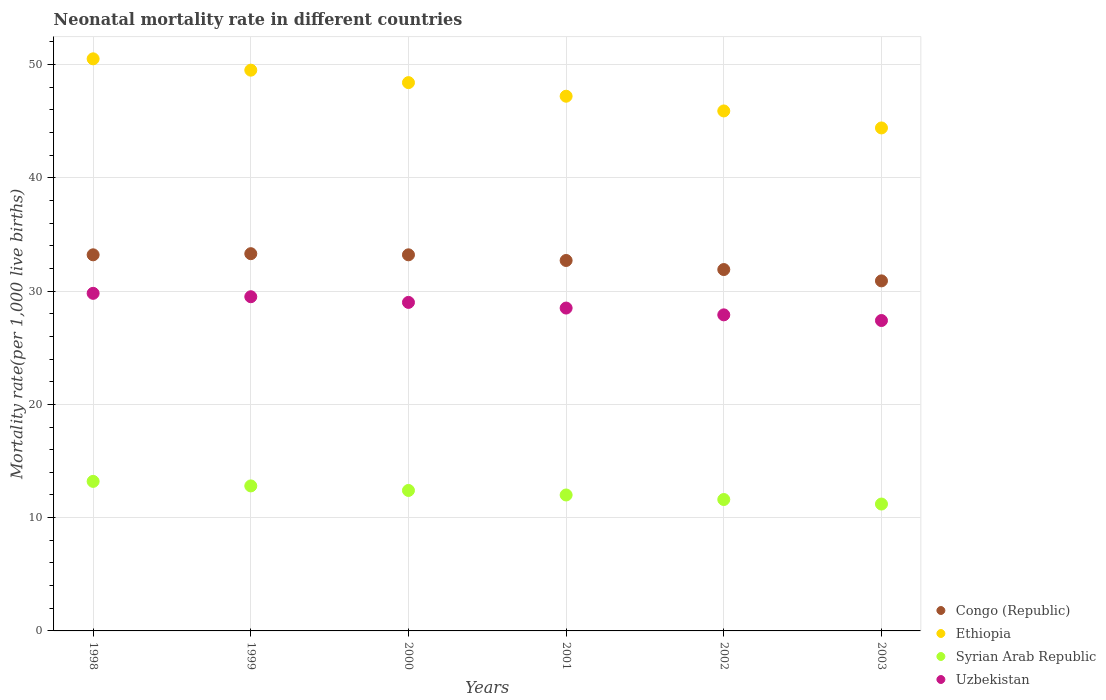What is the neonatal mortality rate in Uzbekistan in 2002?
Provide a succinct answer. 27.9. Across all years, what is the maximum neonatal mortality rate in Ethiopia?
Give a very brief answer. 50.5. Across all years, what is the minimum neonatal mortality rate in Congo (Republic)?
Keep it short and to the point. 30.9. In which year was the neonatal mortality rate in Congo (Republic) maximum?
Your answer should be compact. 1999. What is the total neonatal mortality rate in Syrian Arab Republic in the graph?
Your answer should be very brief. 73.2. What is the difference between the neonatal mortality rate in Ethiopia in 1998 and the neonatal mortality rate in Congo (Republic) in 1999?
Your response must be concise. 17.2. What is the average neonatal mortality rate in Congo (Republic) per year?
Provide a short and direct response. 32.53. In the year 1999, what is the difference between the neonatal mortality rate in Ethiopia and neonatal mortality rate in Syrian Arab Republic?
Your response must be concise. 36.7. In how many years, is the neonatal mortality rate in Uzbekistan greater than 14?
Offer a terse response. 6. What is the ratio of the neonatal mortality rate in Congo (Republic) in 1999 to that in 2000?
Make the answer very short. 1. Is the neonatal mortality rate in Ethiopia in 1998 less than that in 2000?
Make the answer very short. No. Is the difference between the neonatal mortality rate in Ethiopia in 1998 and 2000 greater than the difference between the neonatal mortality rate in Syrian Arab Republic in 1998 and 2000?
Make the answer very short. Yes. What is the difference between the highest and the second highest neonatal mortality rate in Congo (Republic)?
Your answer should be compact. 0.1. In how many years, is the neonatal mortality rate in Uzbekistan greater than the average neonatal mortality rate in Uzbekistan taken over all years?
Provide a succinct answer. 3. Is the sum of the neonatal mortality rate in Uzbekistan in 1998 and 1999 greater than the maximum neonatal mortality rate in Syrian Arab Republic across all years?
Offer a very short reply. Yes. Is it the case that in every year, the sum of the neonatal mortality rate in Congo (Republic) and neonatal mortality rate in Ethiopia  is greater than the sum of neonatal mortality rate in Uzbekistan and neonatal mortality rate in Syrian Arab Republic?
Give a very brief answer. Yes. Is it the case that in every year, the sum of the neonatal mortality rate in Uzbekistan and neonatal mortality rate in Ethiopia  is greater than the neonatal mortality rate in Syrian Arab Republic?
Offer a very short reply. Yes. Does the neonatal mortality rate in Syrian Arab Republic monotonically increase over the years?
Your answer should be very brief. No. How many dotlines are there?
Provide a short and direct response. 4. How many years are there in the graph?
Ensure brevity in your answer.  6. Are the values on the major ticks of Y-axis written in scientific E-notation?
Provide a short and direct response. No. How many legend labels are there?
Ensure brevity in your answer.  4. How are the legend labels stacked?
Your answer should be very brief. Vertical. What is the title of the graph?
Keep it short and to the point. Neonatal mortality rate in different countries. What is the label or title of the X-axis?
Provide a short and direct response. Years. What is the label or title of the Y-axis?
Provide a short and direct response. Mortality rate(per 1,0 live births). What is the Mortality rate(per 1,000 live births) in Congo (Republic) in 1998?
Provide a short and direct response. 33.2. What is the Mortality rate(per 1,000 live births) of Ethiopia in 1998?
Your answer should be very brief. 50.5. What is the Mortality rate(per 1,000 live births) of Syrian Arab Republic in 1998?
Ensure brevity in your answer.  13.2. What is the Mortality rate(per 1,000 live births) of Uzbekistan in 1998?
Your answer should be compact. 29.8. What is the Mortality rate(per 1,000 live births) in Congo (Republic) in 1999?
Your answer should be compact. 33.3. What is the Mortality rate(per 1,000 live births) of Ethiopia in 1999?
Provide a short and direct response. 49.5. What is the Mortality rate(per 1,000 live births) in Uzbekistan in 1999?
Your response must be concise. 29.5. What is the Mortality rate(per 1,000 live births) in Congo (Republic) in 2000?
Give a very brief answer. 33.2. What is the Mortality rate(per 1,000 live births) of Ethiopia in 2000?
Provide a short and direct response. 48.4. What is the Mortality rate(per 1,000 live births) of Uzbekistan in 2000?
Give a very brief answer. 29. What is the Mortality rate(per 1,000 live births) in Congo (Republic) in 2001?
Your answer should be compact. 32.7. What is the Mortality rate(per 1,000 live births) of Ethiopia in 2001?
Your response must be concise. 47.2. What is the Mortality rate(per 1,000 live births) in Uzbekistan in 2001?
Offer a terse response. 28.5. What is the Mortality rate(per 1,000 live births) of Congo (Republic) in 2002?
Provide a short and direct response. 31.9. What is the Mortality rate(per 1,000 live births) of Ethiopia in 2002?
Offer a terse response. 45.9. What is the Mortality rate(per 1,000 live births) of Uzbekistan in 2002?
Your answer should be very brief. 27.9. What is the Mortality rate(per 1,000 live births) of Congo (Republic) in 2003?
Your answer should be very brief. 30.9. What is the Mortality rate(per 1,000 live births) of Ethiopia in 2003?
Provide a short and direct response. 44.4. What is the Mortality rate(per 1,000 live births) of Uzbekistan in 2003?
Offer a terse response. 27.4. Across all years, what is the maximum Mortality rate(per 1,000 live births) of Congo (Republic)?
Ensure brevity in your answer.  33.3. Across all years, what is the maximum Mortality rate(per 1,000 live births) in Ethiopia?
Your answer should be very brief. 50.5. Across all years, what is the maximum Mortality rate(per 1,000 live births) in Syrian Arab Republic?
Provide a short and direct response. 13.2. Across all years, what is the maximum Mortality rate(per 1,000 live births) in Uzbekistan?
Provide a succinct answer. 29.8. Across all years, what is the minimum Mortality rate(per 1,000 live births) in Congo (Republic)?
Your answer should be compact. 30.9. Across all years, what is the minimum Mortality rate(per 1,000 live births) of Ethiopia?
Offer a terse response. 44.4. Across all years, what is the minimum Mortality rate(per 1,000 live births) in Uzbekistan?
Your response must be concise. 27.4. What is the total Mortality rate(per 1,000 live births) in Congo (Republic) in the graph?
Offer a very short reply. 195.2. What is the total Mortality rate(per 1,000 live births) in Ethiopia in the graph?
Give a very brief answer. 285.9. What is the total Mortality rate(per 1,000 live births) in Syrian Arab Republic in the graph?
Keep it short and to the point. 73.2. What is the total Mortality rate(per 1,000 live births) in Uzbekistan in the graph?
Your answer should be very brief. 172.1. What is the difference between the Mortality rate(per 1,000 live births) in Congo (Republic) in 1998 and that in 1999?
Your answer should be very brief. -0.1. What is the difference between the Mortality rate(per 1,000 live births) in Ethiopia in 1998 and that in 1999?
Your answer should be compact. 1. What is the difference between the Mortality rate(per 1,000 live births) of Syrian Arab Republic in 1998 and that in 1999?
Your answer should be very brief. 0.4. What is the difference between the Mortality rate(per 1,000 live births) of Uzbekistan in 1998 and that in 1999?
Make the answer very short. 0.3. What is the difference between the Mortality rate(per 1,000 live births) of Congo (Republic) in 1998 and that in 2000?
Give a very brief answer. 0. What is the difference between the Mortality rate(per 1,000 live births) of Ethiopia in 1998 and that in 2001?
Make the answer very short. 3.3. What is the difference between the Mortality rate(per 1,000 live births) of Syrian Arab Republic in 1998 and that in 2001?
Provide a succinct answer. 1.2. What is the difference between the Mortality rate(per 1,000 live births) of Uzbekistan in 1998 and that in 2001?
Provide a succinct answer. 1.3. What is the difference between the Mortality rate(per 1,000 live births) of Congo (Republic) in 1998 and that in 2002?
Your answer should be very brief. 1.3. What is the difference between the Mortality rate(per 1,000 live births) in Ethiopia in 1998 and that in 2002?
Your answer should be very brief. 4.6. What is the difference between the Mortality rate(per 1,000 live births) in Syrian Arab Republic in 1998 and that in 2002?
Your response must be concise. 1.6. What is the difference between the Mortality rate(per 1,000 live births) in Uzbekistan in 1998 and that in 2002?
Offer a very short reply. 1.9. What is the difference between the Mortality rate(per 1,000 live births) in Syrian Arab Republic in 1998 and that in 2003?
Provide a succinct answer. 2. What is the difference between the Mortality rate(per 1,000 live births) of Uzbekistan in 1998 and that in 2003?
Your answer should be compact. 2.4. What is the difference between the Mortality rate(per 1,000 live births) in Congo (Republic) in 1999 and that in 2000?
Your response must be concise. 0.1. What is the difference between the Mortality rate(per 1,000 live births) in Ethiopia in 1999 and that in 2000?
Your answer should be compact. 1.1. What is the difference between the Mortality rate(per 1,000 live births) in Syrian Arab Republic in 1999 and that in 2000?
Offer a terse response. 0.4. What is the difference between the Mortality rate(per 1,000 live births) in Uzbekistan in 1999 and that in 2000?
Your response must be concise. 0.5. What is the difference between the Mortality rate(per 1,000 live births) of Congo (Republic) in 1999 and that in 2001?
Your answer should be compact. 0.6. What is the difference between the Mortality rate(per 1,000 live births) of Uzbekistan in 1999 and that in 2001?
Your response must be concise. 1. What is the difference between the Mortality rate(per 1,000 live births) of Congo (Republic) in 1999 and that in 2003?
Provide a short and direct response. 2.4. What is the difference between the Mortality rate(per 1,000 live births) of Ethiopia in 2000 and that in 2001?
Offer a very short reply. 1.2. What is the difference between the Mortality rate(per 1,000 live births) of Syrian Arab Republic in 2000 and that in 2001?
Keep it short and to the point. 0.4. What is the difference between the Mortality rate(per 1,000 live births) in Uzbekistan in 2000 and that in 2001?
Your response must be concise. 0.5. What is the difference between the Mortality rate(per 1,000 live births) in Congo (Republic) in 2000 and that in 2002?
Keep it short and to the point. 1.3. What is the difference between the Mortality rate(per 1,000 live births) in Syrian Arab Republic in 2000 and that in 2002?
Give a very brief answer. 0.8. What is the difference between the Mortality rate(per 1,000 live births) in Ethiopia in 2000 and that in 2003?
Offer a terse response. 4. What is the difference between the Mortality rate(per 1,000 live births) of Syrian Arab Republic in 2000 and that in 2003?
Your response must be concise. 1.2. What is the difference between the Mortality rate(per 1,000 live births) in Uzbekistan in 2000 and that in 2003?
Your answer should be compact. 1.6. What is the difference between the Mortality rate(per 1,000 live births) of Congo (Republic) in 2001 and that in 2002?
Offer a very short reply. 0.8. What is the difference between the Mortality rate(per 1,000 live births) of Ethiopia in 2001 and that in 2002?
Your response must be concise. 1.3. What is the difference between the Mortality rate(per 1,000 live births) in Uzbekistan in 2001 and that in 2002?
Ensure brevity in your answer.  0.6. What is the difference between the Mortality rate(per 1,000 live births) of Ethiopia in 2001 and that in 2003?
Your response must be concise. 2.8. What is the difference between the Mortality rate(per 1,000 live births) of Syrian Arab Republic in 2001 and that in 2003?
Keep it short and to the point. 0.8. What is the difference between the Mortality rate(per 1,000 live births) of Syrian Arab Republic in 2002 and that in 2003?
Provide a succinct answer. 0.4. What is the difference between the Mortality rate(per 1,000 live births) of Uzbekistan in 2002 and that in 2003?
Make the answer very short. 0.5. What is the difference between the Mortality rate(per 1,000 live births) in Congo (Republic) in 1998 and the Mortality rate(per 1,000 live births) in Ethiopia in 1999?
Give a very brief answer. -16.3. What is the difference between the Mortality rate(per 1,000 live births) of Congo (Republic) in 1998 and the Mortality rate(per 1,000 live births) of Syrian Arab Republic in 1999?
Ensure brevity in your answer.  20.4. What is the difference between the Mortality rate(per 1,000 live births) in Congo (Republic) in 1998 and the Mortality rate(per 1,000 live births) in Uzbekistan in 1999?
Offer a terse response. 3.7. What is the difference between the Mortality rate(per 1,000 live births) of Ethiopia in 1998 and the Mortality rate(per 1,000 live births) of Syrian Arab Republic in 1999?
Your response must be concise. 37.7. What is the difference between the Mortality rate(per 1,000 live births) in Ethiopia in 1998 and the Mortality rate(per 1,000 live births) in Uzbekistan in 1999?
Make the answer very short. 21. What is the difference between the Mortality rate(per 1,000 live births) of Syrian Arab Republic in 1998 and the Mortality rate(per 1,000 live births) of Uzbekistan in 1999?
Offer a terse response. -16.3. What is the difference between the Mortality rate(per 1,000 live births) of Congo (Republic) in 1998 and the Mortality rate(per 1,000 live births) of Ethiopia in 2000?
Offer a very short reply. -15.2. What is the difference between the Mortality rate(per 1,000 live births) in Congo (Republic) in 1998 and the Mortality rate(per 1,000 live births) in Syrian Arab Republic in 2000?
Keep it short and to the point. 20.8. What is the difference between the Mortality rate(per 1,000 live births) of Ethiopia in 1998 and the Mortality rate(per 1,000 live births) of Syrian Arab Republic in 2000?
Your answer should be compact. 38.1. What is the difference between the Mortality rate(per 1,000 live births) in Syrian Arab Republic in 1998 and the Mortality rate(per 1,000 live births) in Uzbekistan in 2000?
Make the answer very short. -15.8. What is the difference between the Mortality rate(per 1,000 live births) in Congo (Republic) in 1998 and the Mortality rate(per 1,000 live births) in Ethiopia in 2001?
Make the answer very short. -14. What is the difference between the Mortality rate(per 1,000 live births) in Congo (Republic) in 1998 and the Mortality rate(per 1,000 live births) in Syrian Arab Republic in 2001?
Ensure brevity in your answer.  21.2. What is the difference between the Mortality rate(per 1,000 live births) in Ethiopia in 1998 and the Mortality rate(per 1,000 live births) in Syrian Arab Republic in 2001?
Offer a very short reply. 38.5. What is the difference between the Mortality rate(per 1,000 live births) in Syrian Arab Republic in 1998 and the Mortality rate(per 1,000 live births) in Uzbekistan in 2001?
Provide a succinct answer. -15.3. What is the difference between the Mortality rate(per 1,000 live births) in Congo (Republic) in 1998 and the Mortality rate(per 1,000 live births) in Ethiopia in 2002?
Offer a terse response. -12.7. What is the difference between the Mortality rate(per 1,000 live births) in Congo (Republic) in 1998 and the Mortality rate(per 1,000 live births) in Syrian Arab Republic in 2002?
Provide a short and direct response. 21.6. What is the difference between the Mortality rate(per 1,000 live births) of Congo (Republic) in 1998 and the Mortality rate(per 1,000 live births) of Uzbekistan in 2002?
Provide a short and direct response. 5.3. What is the difference between the Mortality rate(per 1,000 live births) in Ethiopia in 1998 and the Mortality rate(per 1,000 live births) in Syrian Arab Republic in 2002?
Offer a terse response. 38.9. What is the difference between the Mortality rate(per 1,000 live births) in Ethiopia in 1998 and the Mortality rate(per 1,000 live births) in Uzbekistan in 2002?
Make the answer very short. 22.6. What is the difference between the Mortality rate(per 1,000 live births) in Syrian Arab Republic in 1998 and the Mortality rate(per 1,000 live births) in Uzbekistan in 2002?
Offer a very short reply. -14.7. What is the difference between the Mortality rate(per 1,000 live births) of Congo (Republic) in 1998 and the Mortality rate(per 1,000 live births) of Ethiopia in 2003?
Provide a succinct answer. -11.2. What is the difference between the Mortality rate(per 1,000 live births) in Ethiopia in 1998 and the Mortality rate(per 1,000 live births) in Syrian Arab Republic in 2003?
Your response must be concise. 39.3. What is the difference between the Mortality rate(per 1,000 live births) of Ethiopia in 1998 and the Mortality rate(per 1,000 live births) of Uzbekistan in 2003?
Offer a terse response. 23.1. What is the difference between the Mortality rate(per 1,000 live births) in Congo (Republic) in 1999 and the Mortality rate(per 1,000 live births) in Ethiopia in 2000?
Provide a succinct answer. -15.1. What is the difference between the Mortality rate(per 1,000 live births) in Congo (Republic) in 1999 and the Mortality rate(per 1,000 live births) in Syrian Arab Republic in 2000?
Your answer should be very brief. 20.9. What is the difference between the Mortality rate(per 1,000 live births) of Congo (Republic) in 1999 and the Mortality rate(per 1,000 live births) of Uzbekistan in 2000?
Your response must be concise. 4.3. What is the difference between the Mortality rate(per 1,000 live births) of Ethiopia in 1999 and the Mortality rate(per 1,000 live births) of Syrian Arab Republic in 2000?
Ensure brevity in your answer.  37.1. What is the difference between the Mortality rate(per 1,000 live births) in Ethiopia in 1999 and the Mortality rate(per 1,000 live births) in Uzbekistan in 2000?
Offer a very short reply. 20.5. What is the difference between the Mortality rate(per 1,000 live births) in Syrian Arab Republic in 1999 and the Mortality rate(per 1,000 live births) in Uzbekistan in 2000?
Keep it short and to the point. -16.2. What is the difference between the Mortality rate(per 1,000 live births) in Congo (Republic) in 1999 and the Mortality rate(per 1,000 live births) in Syrian Arab Republic in 2001?
Your response must be concise. 21.3. What is the difference between the Mortality rate(per 1,000 live births) in Ethiopia in 1999 and the Mortality rate(per 1,000 live births) in Syrian Arab Republic in 2001?
Give a very brief answer. 37.5. What is the difference between the Mortality rate(per 1,000 live births) in Ethiopia in 1999 and the Mortality rate(per 1,000 live births) in Uzbekistan in 2001?
Make the answer very short. 21. What is the difference between the Mortality rate(per 1,000 live births) in Syrian Arab Republic in 1999 and the Mortality rate(per 1,000 live births) in Uzbekistan in 2001?
Offer a terse response. -15.7. What is the difference between the Mortality rate(per 1,000 live births) of Congo (Republic) in 1999 and the Mortality rate(per 1,000 live births) of Syrian Arab Republic in 2002?
Your answer should be very brief. 21.7. What is the difference between the Mortality rate(per 1,000 live births) in Congo (Republic) in 1999 and the Mortality rate(per 1,000 live births) in Uzbekistan in 2002?
Keep it short and to the point. 5.4. What is the difference between the Mortality rate(per 1,000 live births) in Ethiopia in 1999 and the Mortality rate(per 1,000 live births) in Syrian Arab Republic in 2002?
Keep it short and to the point. 37.9. What is the difference between the Mortality rate(per 1,000 live births) of Ethiopia in 1999 and the Mortality rate(per 1,000 live births) of Uzbekistan in 2002?
Offer a very short reply. 21.6. What is the difference between the Mortality rate(per 1,000 live births) in Syrian Arab Republic in 1999 and the Mortality rate(per 1,000 live births) in Uzbekistan in 2002?
Your answer should be compact. -15.1. What is the difference between the Mortality rate(per 1,000 live births) in Congo (Republic) in 1999 and the Mortality rate(per 1,000 live births) in Syrian Arab Republic in 2003?
Your response must be concise. 22.1. What is the difference between the Mortality rate(per 1,000 live births) in Congo (Republic) in 1999 and the Mortality rate(per 1,000 live births) in Uzbekistan in 2003?
Your response must be concise. 5.9. What is the difference between the Mortality rate(per 1,000 live births) of Ethiopia in 1999 and the Mortality rate(per 1,000 live births) of Syrian Arab Republic in 2003?
Make the answer very short. 38.3. What is the difference between the Mortality rate(per 1,000 live births) of Ethiopia in 1999 and the Mortality rate(per 1,000 live births) of Uzbekistan in 2003?
Your answer should be very brief. 22.1. What is the difference between the Mortality rate(per 1,000 live births) of Syrian Arab Republic in 1999 and the Mortality rate(per 1,000 live births) of Uzbekistan in 2003?
Keep it short and to the point. -14.6. What is the difference between the Mortality rate(per 1,000 live births) in Congo (Republic) in 2000 and the Mortality rate(per 1,000 live births) in Ethiopia in 2001?
Keep it short and to the point. -14. What is the difference between the Mortality rate(per 1,000 live births) in Congo (Republic) in 2000 and the Mortality rate(per 1,000 live births) in Syrian Arab Republic in 2001?
Provide a short and direct response. 21.2. What is the difference between the Mortality rate(per 1,000 live births) of Ethiopia in 2000 and the Mortality rate(per 1,000 live births) of Syrian Arab Republic in 2001?
Offer a very short reply. 36.4. What is the difference between the Mortality rate(per 1,000 live births) of Syrian Arab Republic in 2000 and the Mortality rate(per 1,000 live births) of Uzbekistan in 2001?
Provide a short and direct response. -16.1. What is the difference between the Mortality rate(per 1,000 live births) of Congo (Republic) in 2000 and the Mortality rate(per 1,000 live births) of Syrian Arab Republic in 2002?
Your answer should be compact. 21.6. What is the difference between the Mortality rate(per 1,000 live births) in Ethiopia in 2000 and the Mortality rate(per 1,000 live births) in Syrian Arab Republic in 2002?
Your answer should be very brief. 36.8. What is the difference between the Mortality rate(per 1,000 live births) of Syrian Arab Republic in 2000 and the Mortality rate(per 1,000 live births) of Uzbekistan in 2002?
Offer a very short reply. -15.5. What is the difference between the Mortality rate(per 1,000 live births) in Congo (Republic) in 2000 and the Mortality rate(per 1,000 live births) in Syrian Arab Republic in 2003?
Keep it short and to the point. 22. What is the difference between the Mortality rate(per 1,000 live births) in Ethiopia in 2000 and the Mortality rate(per 1,000 live births) in Syrian Arab Republic in 2003?
Keep it short and to the point. 37.2. What is the difference between the Mortality rate(per 1,000 live births) in Syrian Arab Republic in 2000 and the Mortality rate(per 1,000 live births) in Uzbekistan in 2003?
Provide a short and direct response. -15. What is the difference between the Mortality rate(per 1,000 live births) in Congo (Republic) in 2001 and the Mortality rate(per 1,000 live births) in Syrian Arab Republic in 2002?
Your answer should be compact. 21.1. What is the difference between the Mortality rate(per 1,000 live births) in Congo (Republic) in 2001 and the Mortality rate(per 1,000 live births) in Uzbekistan in 2002?
Ensure brevity in your answer.  4.8. What is the difference between the Mortality rate(per 1,000 live births) of Ethiopia in 2001 and the Mortality rate(per 1,000 live births) of Syrian Arab Republic in 2002?
Your answer should be very brief. 35.6. What is the difference between the Mortality rate(per 1,000 live births) of Ethiopia in 2001 and the Mortality rate(per 1,000 live births) of Uzbekistan in 2002?
Keep it short and to the point. 19.3. What is the difference between the Mortality rate(per 1,000 live births) of Syrian Arab Republic in 2001 and the Mortality rate(per 1,000 live births) of Uzbekistan in 2002?
Keep it short and to the point. -15.9. What is the difference between the Mortality rate(per 1,000 live births) of Congo (Republic) in 2001 and the Mortality rate(per 1,000 live births) of Ethiopia in 2003?
Provide a succinct answer. -11.7. What is the difference between the Mortality rate(per 1,000 live births) of Ethiopia in 2001 and the Mortality rate(per 1,000 live births) of Uzbekistan in 2003?
Provide a succinct answer. 19.8. What is the difference between the Mortality rate(per 1,000 live births) in Syrian Arab Republic in 2001 and the Mortality rate(per 1,000 live births) in Uzbekistan in 2003?
Your response must be concise. -15.4. What is the difference between the Mortality rate(per 1,000 live births) of Congo (Republic) in 2002 and the Mortality rate(per 1,000 live births) of Ethiopia in 2003?
Provide a succinct answer. -12.5. What is the difference between the Mortality rate(per 1,000 live births) of Congo (Republic) in 2002 and the Mortality rate(per 1,000 live births) of Syrian Arab Republic in 2003?
Your answer should be very brief. 20.7. What is the difference between the Mortality rate(per 1,000 live births) in Congo (Republic) in 2002 and the Mortality rate(per 1,000 live births) in Uzbekistan in 2003?
Offer a very short reply. 4.5. What is the difference between the Mortality rate(per 1,000 live births) of Ethiopia in 2002 and the Mortality rate(per 1,000 live births) of Syrian Arab Republic in 2003?
Ensure brevity in your answer.  34.7. What is the difference between the Mortality rate(per 1,000 live births) in Ethiopia in 2002 and the Mortality rate(per 1,000 live births) in Uzbekistan in 2003?
Provide a short and direct response. 18.5. What is the difference between the Mortality rate(per 1,000 live births) of Syrian Arab Republic in 2002 and the Mortality rate(per 1,000 live births) of Uzbekistan in 2003?
Your answer should be compact. -15.8. What is the average Mortality rate(per 1,000 live births) in Congo (Republic) per year?
Give a very brief answer. 32.53. What is the average Mortality rate(per 1,000 live births) of Ethiopia per year?
Provide a short and direct response. 47.65. What is the average Mortality rate(per 1,000 live births) in Syrian Arab Republic per year?
Your answer should be compact. 12.2. What is the average Mortality rate(per 1,000 live births) in Uzbekistan per year?
Provide a short and direct response. 28.68. In the year 1998, what is the difference between the Mortality rate(per 1,000 live births) of Congo (Republic) and Mortality rate(per 1,000 live births) of Ethiopia?
Offer a very short reply. -17.3. In the year 1998, what is the difference between the Mortality rate(per 1,000 live births) in Congo (Republic) and Mortality rate(per 1,000 live births) in Syrian Arab Republic?
Make the answer very short. 20. In the year 1998, what is the difference between the Mortality rate(per 1,000 live births) in Ethiopia and Mortality rate(per 1,000 live births) in Syrian Arab Republic?
Keep it short and to the point. 37.3. In the year 1998, what is the difference between the Mortality rate(per 1,000 live births) in Ethiopia and Mortality rate(per 1,000 live births) in Uzbekistan?
Your answer should be compact. 20.7. In the year 1998, what is the difference between the Mortality rate(per 1,000 live births) of Syrian Arab Republic and Mortality rate(per 1,000 live births) of Uzbekistan?
Offer a very short reply. -16.6. In the year 1999, what is the difference between the Mortality rate(per 1,000 live births) of Congo (Republic) and Mortality rate(per 1,000 live births) of Ethiopia?
Your answer should be very brief. -16.2. In the year 1999, what is the difference between the Mortality rate(per 1,000 live births) in Ethiopia and Mortality rate(per 1,000 live births) in Syrian Arab Republic?
Provide a short and direct response. 36.7. In the year 1999, what is the difference between the Mortality rate(per 1,000 live births) in Syrian Arab Republic and Mortality rate(per 1,000 live births) in Uzbekistan?
Your answer should be compact. -16.7. In the year 2000, what is the difference between the Mortality rate(per 1,000 live births) of Congo (Republic) and Mortality rate(per 1,000 live births) of Ethiopia?
Make the answer very short. -15.2. In the year 2000, what is the difference between the Mortality rate(per 1,000 live births) of Congo (Republic) and Mortality rate(per 1,000 live births) of Syrian Arab Republic?
Make the answer very short. 20.8. In the year 2000, what is the difference between the Mortality rate(per 1,000 live births) of Syrian Arab Republic and Mortality rate(per 1,000 live births) of Uzbekistan?
Your answer should be very brief. -16.6. In the year 2001, what is the difference between the Mortality rate(per 1,000 live births) in Congo (Republic) and Mortality rate(per 1,000 live births) in Syrian Arab Republic?
Provide a short and direct response. 20.7. In the year 2001, what is the difference between the Mortality rate(per 1,000 live births) of Ethiopia and Mortality rate(per 1,000 live births) of Syrian Arab Republic?
Your answer should be compact. 35.2. In the year 2001, what is the difference between the Mortality rate(per 1,000 live births) of Syrian Arab Republic and Mortality rate(per 1,000 live births) of Uzbekistan?
Provide a succinct answer. -16.5. In the year 2002, what is the difference between the Mortality rate(per 1,000 live births) in Congo (Republic) and Mortality rate(per 1,000 live births) in Syrian Arab Republic?
Make the answer very short. 20.3. In the year 2002, what is the difference between the Mortality rate(per 1,000 live births) of Congo (Republic) and Mortality rate(per 1,000 live births) of Uzbekistan?
Your response must be concise. 4. In the year 2002, what is the difference between the Mortality rate(per 1,000 live births) in Ethiopia and Mortality rate(per 1,000 live births) in Syrian Arab Republic?
Ensure brevity in your answer.  34.3. In the year 2002, what is the difference between the Mortality rate(per 1,000 live births) of Syrian Arab Republic and Mortality rate(per 1,000 live births) of Uzbekistan?
Offer a terse response. -16.3. In the year 2003, what is the difference between the Mortality rate(per 1,000 live births) in Congo (Republic) and Mortality rate(per 1,000 live births) in Syrian Arab Republic?
Make the answer very short. 19.7. In the year 2003, what is the difference between the Mortality rate(per 1,000 live births) of Ethiopia and Mortality rate(per 1,000 live births) of Syrian Arab Republic?
Your response must be concise. 33.2. In the year 2003, what is the difference between the Mortality rate(per 1,000 live births) in Syrian Arab Republic and Mortality rate(per 1,000 live births) in Uzbekistan?
Offer a terse response. -16.2. What is the ratio of the Mortality rate(per 1,000 live births) in Ethiopia in 1998 to that in 1999?
Ensure brevity in your answer.  1.02. What is the ratio of the Mortality rate(per 1,000 live births) of Syrian Arab Republic in 1998 to that in 1999?
Provide a succinct answer. 1.03. What is the ratio of the Mortality rate(per 1,000 live births) in Uzbekistan in 1998 to that in 1999?
Ensure brevity in your answer.  1.01. What is the ratio of the Mortality rate(per 1,000 live births) of Congo (Republic) in 1998 to that in 2000?
Keep it short and to the point. 1. What is the ratio of the Mortality rate(per 1,000 live births) of Ethiopia in 1998 to that in 2000?
Keep it short and to the point. 1.04. What is the ratio of the Mortality rate(per 1,000 live births) in Syrian Arab Republic in 1998 to that in 2000?
Offer a terse response. 1.06. What is the ratio of the Mortality rate(per 1,000 live births) in Uzbekistan in 1998 to that in 2000?
Offer a terse response. 1.03. What is the ratio of the Mortality rate(per 1,000 live births) in Congo (Republic) in 1998 to that in 2001?
Ensure brevity in your answer.  1.02. What is the ratio of the Mortality rate(per 1,000 live births) in Ethiopia in 1998 to that in 2001?
Offer a very short reply. 1.07. What is the ratio of the Mortality rate(per 1,000 live births) of Syrian Arab Republic in 1998 to that in 2001?
Offer a very short reply. 1.1. What is the ratio of the Mortality rate(per 1,000 live births) in Uzbekistan in 1998 to that in 2001?
Provide a short and direct response. 1.05. What is the ratio of the Mortality rate(per 1,000 live births) in Congo (Republic) in 1998 to that in 2002?
Keep it short and to the point. 1.04. What is the ratio of the Mortality rate(per 1,000 live births) of Ethiopia in 1998 to that in 2002?
Provide a short and direct response. 1.1. What is the ratio of the Mortality rate(per 1,000 live births) of Syrian Arab Republic in 1998 to that in 2002?
Ensure brevity in your answer.  1.14. What is the ratio of the Mortality rate(per 1,000 live births) of Uzbekistan in 1998 to that in 2002?
Make the answer very short. 1.07. What is the ratio of the Mortality rate(per 1,000 live births) of Congo (Republic) in 1998 to that in 2003?
Ensure brevity in your answer.  1.07. What is the ratio of the Mortality rate(per 1,000 live births) of Ethiopia in 1998 to that in 2003?
Offer a very short reply. 1.14. What is the ratio of the Mortality rate(per 1,000 live births) in Syrian Arab Republic in 1998 to that in 2003?
Make the answer very short. 1.18. What is the ratio of the Mortality rate(per 1,000 live births) of Uzbekistan in 1998 to that in 2003?
Give a very brief answer. 1.09. What is the ratio of the Mortality rate(per 1,000 live births) in Congo (Republic) in 1999 to that in 2000?
Your answer should be compact. 1. What is the ratio of the Mortality rate(per 1,000 live births) of Ethiopia in 1999 to that in 2000?
Your answer should be compact. 1.02. What is the ratio of the Mortality rate(per 1,000 live births) in Syrian Arab Republic in 1999 to that in 2000?
Offer a terse response. 1.03. What is the ratio of the Mortality rate(per 1,000 live births) of Uzbekistan in 1999 to that in 2000?
Offer a terse response. 1.02. What is the ratio of the Mortality rate(per 1,000 live births) of Congo (Republic) in 1999 to that in 2001?
Ensure brevity in your answer.  1.02. What is the ratio of the Mortality rate(per 1,000 live births) in Ethiopia in 1999 to that in 2001?
Keep it short and to the point. 1.05. What is the ratio of the Mortality rate(per 1,000 live births) in Syrian Arab Republic in 1999 to that in 2001?
Keep it short and to the point. 1.07. What is the ratio of the Mortality rate(per 1,000 live births) in Uzbekistan in 1999 to that in 2001?
Provide a succinct answer. 1.04. What is the ratio of the Mortality rate(per 1,000 live births) of Congo (Republic) in 1999 to that in 2002?
Your response must be concise. 1.04. What is the ratio of the Mortality rate(per 1,000 live births) of Ethiopia in 1999 to that in 2002?
Your response must be concise. 1.08. What is the ratio of the Mortality rate(per 1,000 live births) in Syrian Arab Republic in 1999 to that in 2002?
Your answer should be very brief. 1.1. What is the ratio of the Mortality rate(per 1,000 live births) in Uzbekistan in 1999 to that in 2002?
Give a very brief answer. 1.06. What is the ratio of the Mortality rate(per 1,000 live births) of Congo (Republic) in 1999 to that in 2003?
Provide a succinct answer. 1.08. What is the ratio of the Mortality rate(per 1,000 live births) of Ethiopia in 1999 to that in 2003?
Keep it short and to the point. 1.11. What is the ratio of the Mortality rate(per 1,000 live births) in Uzbekistan in 1999 to that in 2003?
Offer a terse response. 1.08. What is the ratio of the Mortality rate(per 1,000 live births) in Congo (Republic) in 2000 to that in 2001?
Provide a succinct answer. 1.02. What is the ratio of the Mortality rate(per 1,000 live births) in Ethiopia in 2000 to that in 2001?
Provide a short and direct response. 1.03. What is the ratio of the Mortality rate(per 1,000 live births) in Uzbekistan in 2000 to that in 2001?
Offer a very short reply. 1.02. What is the ratio of the Mortality rate(per 1,000 live births) of Congo (Republic) in 2000 to that in 2002?
Offer a very short reply. 1.04. What is the ratio of the Mortality rate(per 1,000 live births) in Ethiopia in 2000 to that in 2002?
Ensure brevity in your answer.  1.05. What is the ratio of the Mortality rate(per 1,000 live births) in Syrian Arab Republic in 2000 to that in 2002?
Keep it short and to the point. 1.07. What is the ratio of the Mortality rate(per 1,000 live births) of Uzbekistan in 2000 to that in 2002?
Provide a short and direct response. 1.04. What is the ratio of the Mortality rate(per 1,000 live births) of Congo (Republic) in 2000 to that in 2003?
Ensure brevity in your answer.  1.07. What is the ratio of the Mortality rate(per 1,000 live births) of Ethiopia in 2000 to that in 2003?
Provide a succinct answer. 1.09. What is the ratio of the Mortality rate(per 1,000 live births) of Syrian Arab Republic in 2000 to that in 2003?
Ensure brevity in your answer.  1.11. What is the ratio of the Mortality rate(per 1,000 live births) in Uzbekistan in 2000 to that in 2003?
Make the answer very short. 1.06. What is the ratio of the Mortality rate(per 1,000 live births) of Congo (Republic) in 2001 to that in 2002?
Your answer should be compact. 1.03. What is the ratio of the Mortality rate(per 1,000 live births) of Ethiopia in 2001 to that in 2002?
Your answer should be very brief. 1.03. What is the ratio of the Mortality rate(per 1,000 live births) of Syrian Arab Republic in 2001 to that in 2002?
Give a very brief answer. 1.03. What is the ratio of the Mortality rate(per 1,000 live births) of Uzbekistan in 2001 to that in 2002?
Provide a succinct answer. 1.02. What is the ratio of the Mortality rate(per 1,000 live births) of Congo (Republic) in 2001 to that in 2003?
Offer a very short reply. 1.06. What is the ratio of the Mortality rate(per 1,000 live births) in Ethiopia in 2001 to that in 2003?
Your response must be concise. 1.06. What is the ratio of the Mortality rate(per 1,000 live births) in Syrian Arab Republic in 2001 to that in 2003?
Make the answer very short. 1.07. What is the ratio of the Mortality rate(per 1,000 live births) of Uzbekistan in 2001 to that in 2003?
Provide a succinct answer. 1.04. What is the ratio of the Mortality rate(per 1,000 live births) in Congo (Republic) in 2002 to that in 2003?
Offer a terse response. 1.03. What is the ratio of the Mortality rate(per 1,000 live births) in Ethiopia in 2002 to that in 2003?
Provide a short and direct response. 1.03. What is the ratio of the Mortality rate(per 1,000 live births) in Syrian Arab Republic in 2002 to that in 2003?
Make the answer very short. 1.04. What is the ratio of the Mortality rate(per 1,000 live births) of Uzbekistan in 2002 to that in 2003?
Provide a short and direct response. 1.02. What is the difference between the highest and the second highest Mortality rate(per 1,000 live births) in Congo (Republic)?
Your answer should be compact. 0.1. What is the difference between the highest and the second highest Mortality rate(per 1,000 live births) in Syrian Arab Republic?
Offer a terse response. 0.4. What is the difference between the highest and the second highest Mortality rate(per 1,000 live births) in Uzbekistan?
Your answer should be very brief. 0.3. What is the difference between the highest and the lowest Mortality rate(per 1,000 live births) of Congo (Republic)?
Give a very brief answer. 2.4. What is the difference between the highest and the lowest Mortality rate(per 1,000 live births) of Uzbekistan?
Your answer should be compact. 2.4. 